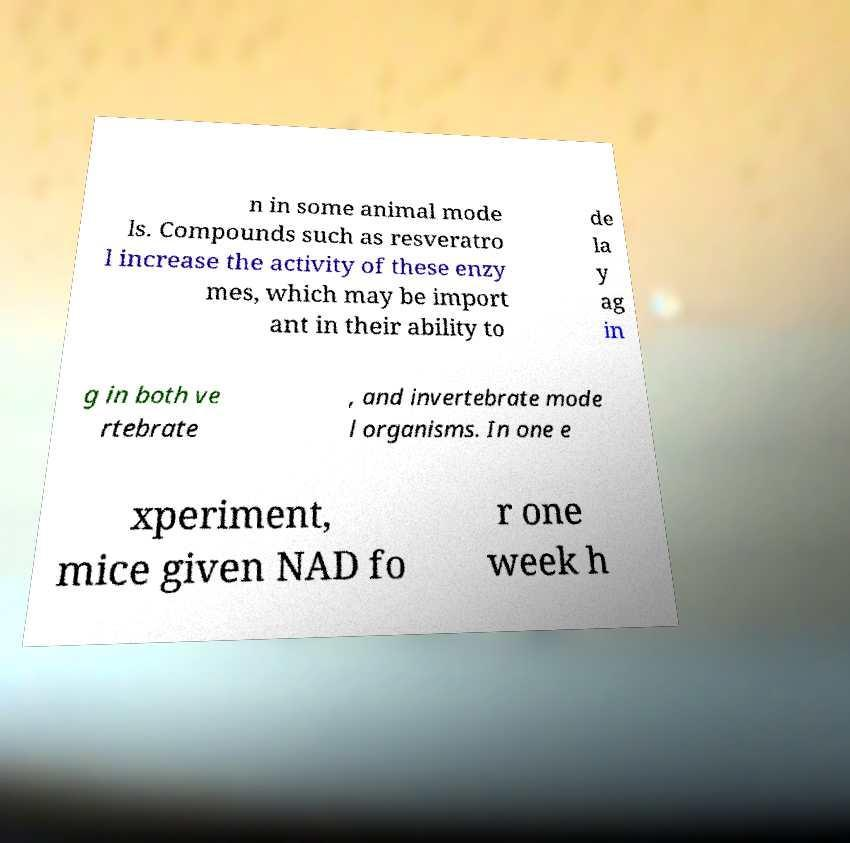Can you accurately transcribe the text from the provided image for me? n in some animal mode ls. Compounds such as resveratro l increase the activity of these enzy mes, which may be import ant in their ability to de la y ag in g in both ve rtebrate , and invertebrate mode l organisms. In one e xperiment, mice given NAD fo r one week h 